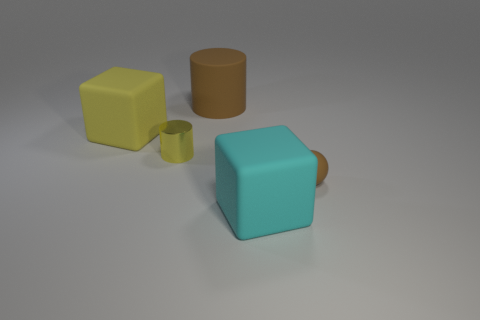What number of other things are there of the same size as the metallic cylinder?
Your response must be concise. 1. Are there any other things that are the same color as the small cylinder?
Ensure brevity in your answer.  Yes. There is a brown object that is made of the same material as the large cylinder; what shape is it?
Keep it short and to the point. Sphere. Are the large block that is right of the big cylinder and the small cylinder made of the same material?
Ensure brevity in your answer.  No. The thing that is the same color as the matte ball is what shape?
Provide a succinct answer. Cylinder. There is a large matte cube that is behind the tiny brown rubber ball; does it have the same color as the large block in front of the yellow metal object?
Keep it short and to the point. No. What number of big matte things are in front of the matte cylinder and to the left of the large cyan block?
Your answer should be very brief. 1. What is the material of the brown sphere?
Your answer should be compact. Rubber. There is a brown matte object that is the same size as the cyan block; what is its shape?
Keep it short and to the point. Cylinder. Do the cylinder that is left of the rubber cylinder and the big block behind the tiny yellow thing have the same material?
Your response must be concise. No. 